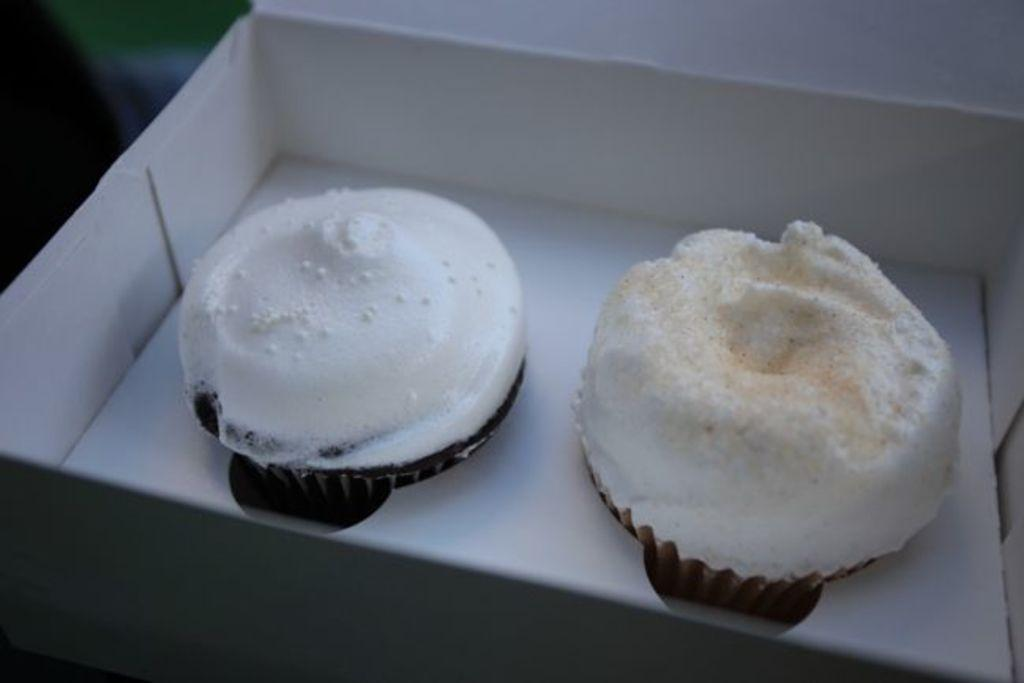What type of food can be seen in the image? There are desserts in the image. How are the desserts arranged or contained in the image? The desserts are in a box. What level of government is responsible for regulating the desserts in the image? There is no indication of government involvement or regulation in the image, as it simply shows desserts in a box. 